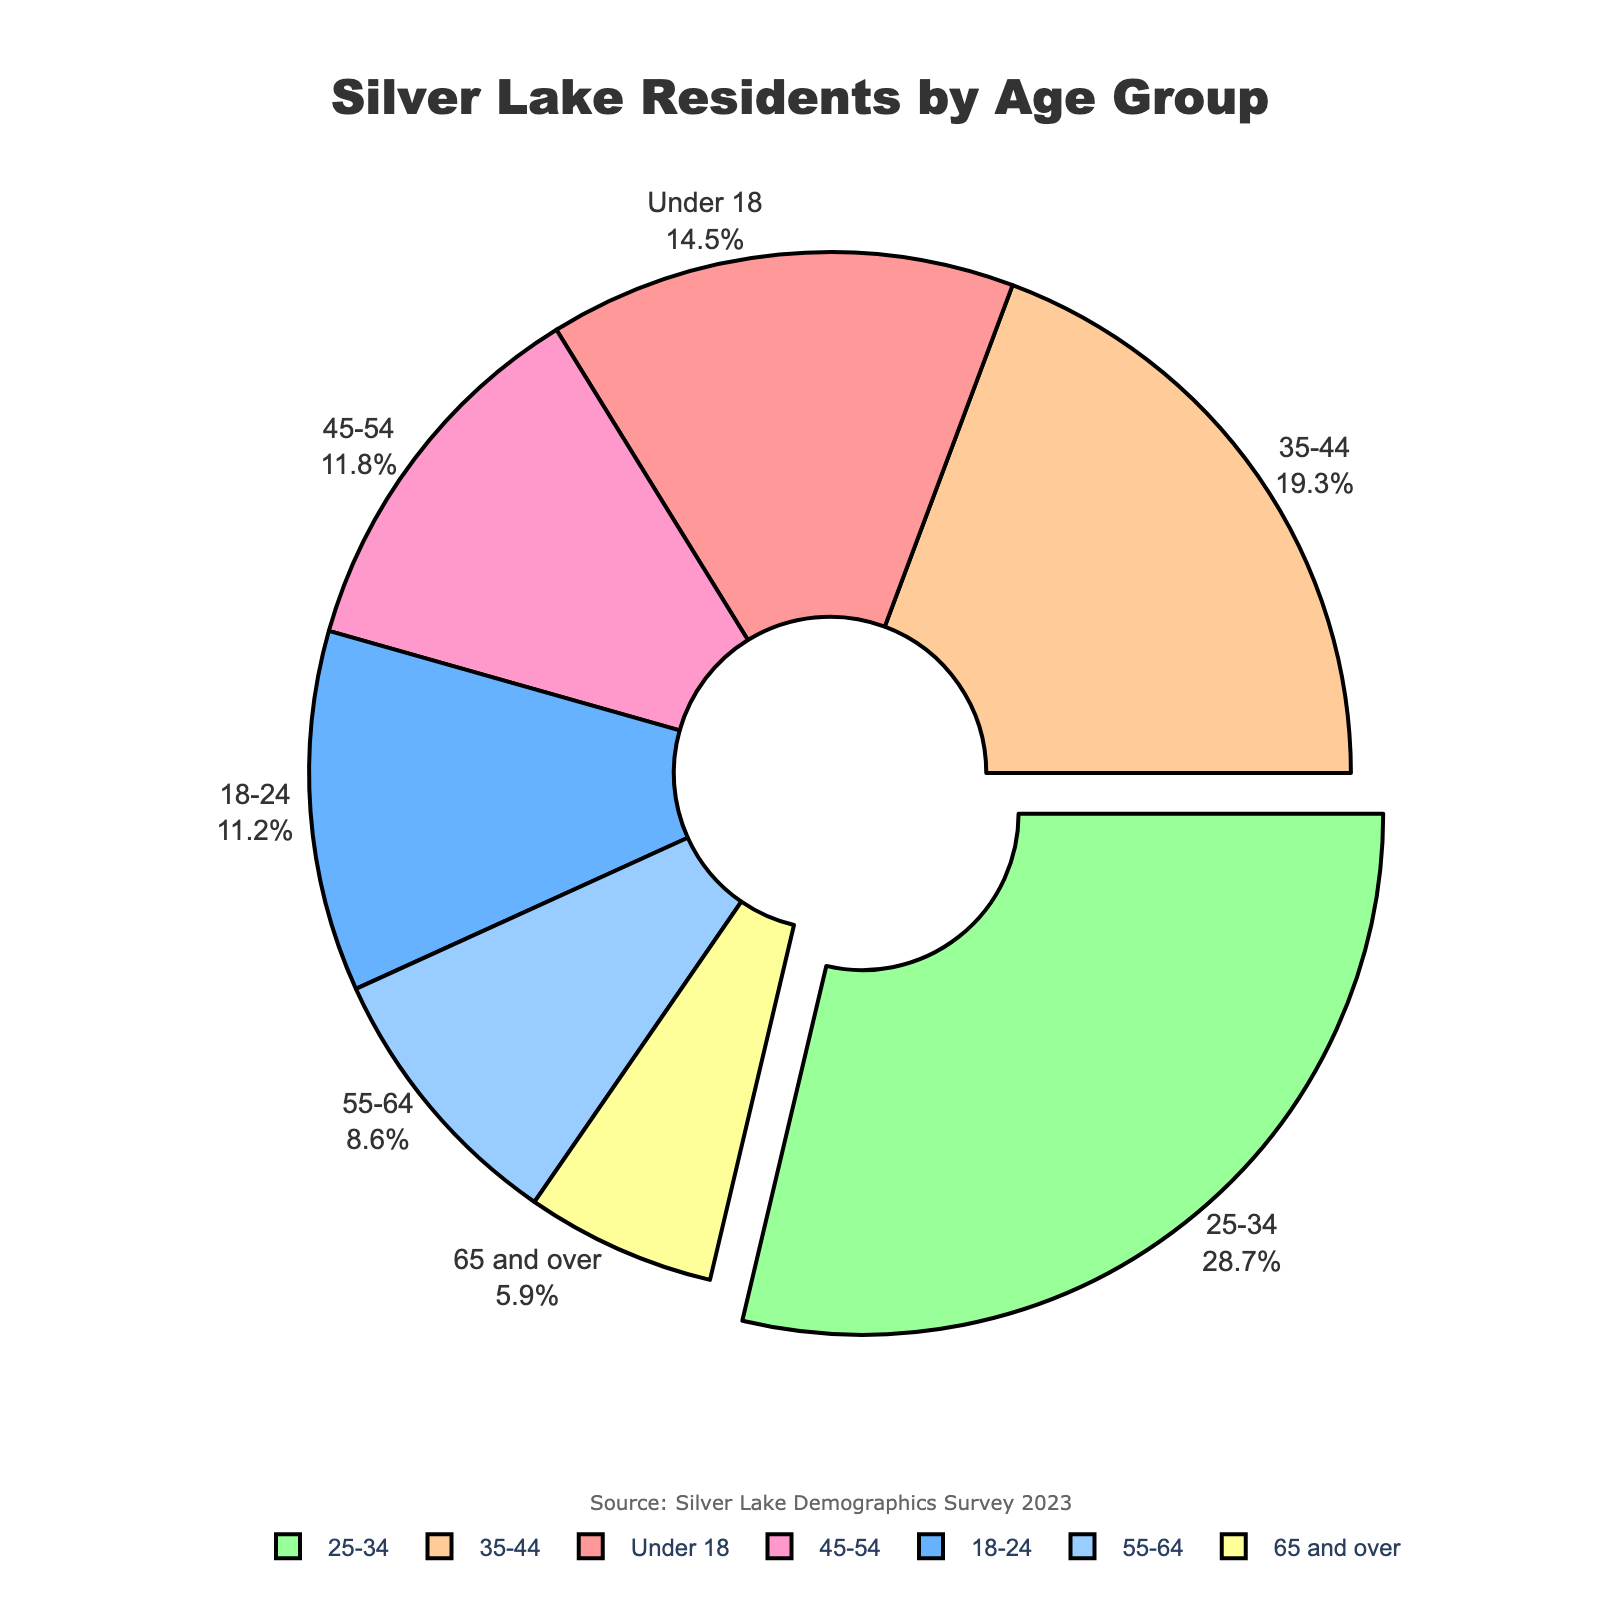what age group has the largest percentage of residents in Silver Lake? The pie chart shows that the age group 25-34 has the largest segment, visually indicated by its size and the percentage label provided outside the segment.
Answer: 25-34 What is the combined percentage of residents under 18 and residents 65 and over? The percentage of residents under 18 is 14.5%, and the percentage of residents 65 and over is 5.9%. By adding these two percentages, we get 14.5 + 5.9 = 20.4%.
Answer: 20.4% Which age group has the smallest percentage of residents? By examining the sizes of the segments and the percentage labels, the age group 65 and over has the smallest percentage at 5.9%.
Answer: 65 and over What is the percentage difference between age groups 25-34 and 18-24? The percentage for the age group 25-34 is 28.7%, and for the age group 18-24 is 11.2%. The difference is calculated as 28.7 - 11.2 = 17.5%.
Answer: 17.5% What is the ratio of residents aged 35-44 to those aged 55-64? The percentage for the age group 35-44 is 19.3%, and for the age group 55-64 is 8.6%. The ratio is found by dividing the percentages: 19.3 / 8.6 ≈ 2.24.
Answer: 2.24 Which age group's segment is pulled out from the pie chart? The visually noticeable element of the pie chart is that the largest segment, representing the age group 25-34, is pulled out from the pie for emphasis.
Answer: 25-34 Are there more residents aged 18-24 or 45-54 in Silver Lake? The pie chart indicates that the percentage of residents aged 18-24 is 11.2%, while that of 45-54 is 11.8%. Therefore, there are more residents aged 45-54.
Answer: 45-54 What is the percentage of residents aged 55 and over? The age groups 55-64 and 65 and over combined have percentages of 8.6% and 5.9%, respectively. Adding these together gives 8.6 + 5.9 = 14.5%.
Answer: 14.5% Which color represents the age group 35-44? The pie chart uses a specific color scheme to represent each age group. The color for the age group 35-44 is identified visually, but based on the scheme, it appears as an orange shade.
Answer: orange 